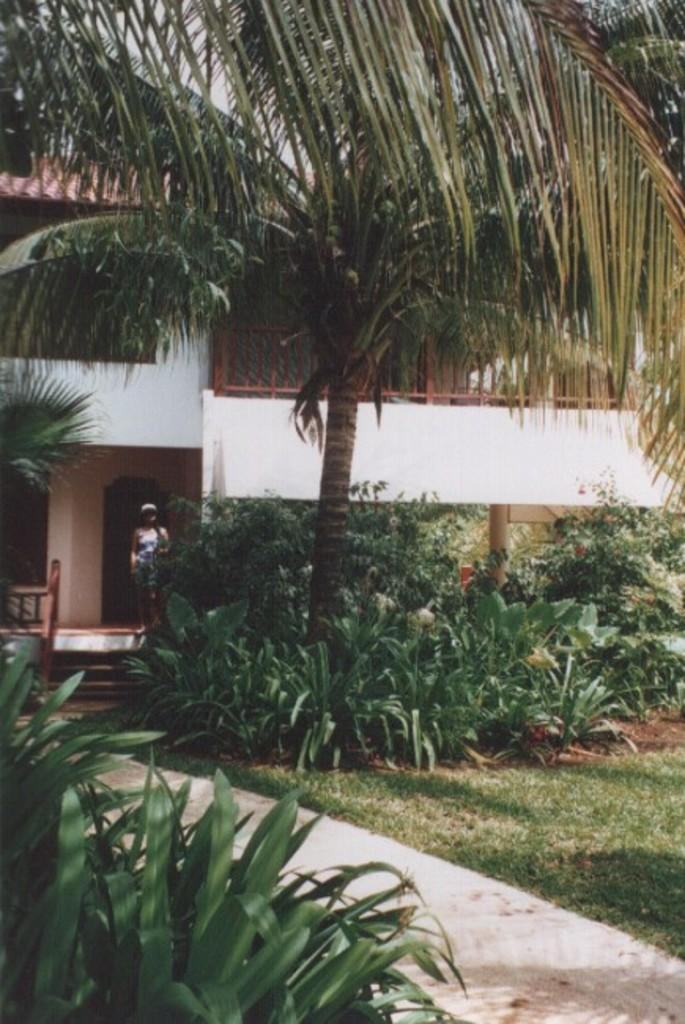What type of surface can be seen in the image? There is a path in the image. What type of vegetation is present around the path? Grass is present around the path. What other types of vegetation can be seen in the image? There are plants and trees visible in the image. What structure is located behind the trees? There is a house behind the trees. Who is present in front of the house? A woman is standing in front of the house. What type of current can be seen flowing through the image? There is no current visible in the image; it is a path surrounded by vegetation and a house. How many crows are perched on the trees in the image? There are no crows present in the image; it features a path, vegetation, a house, and a woman. 